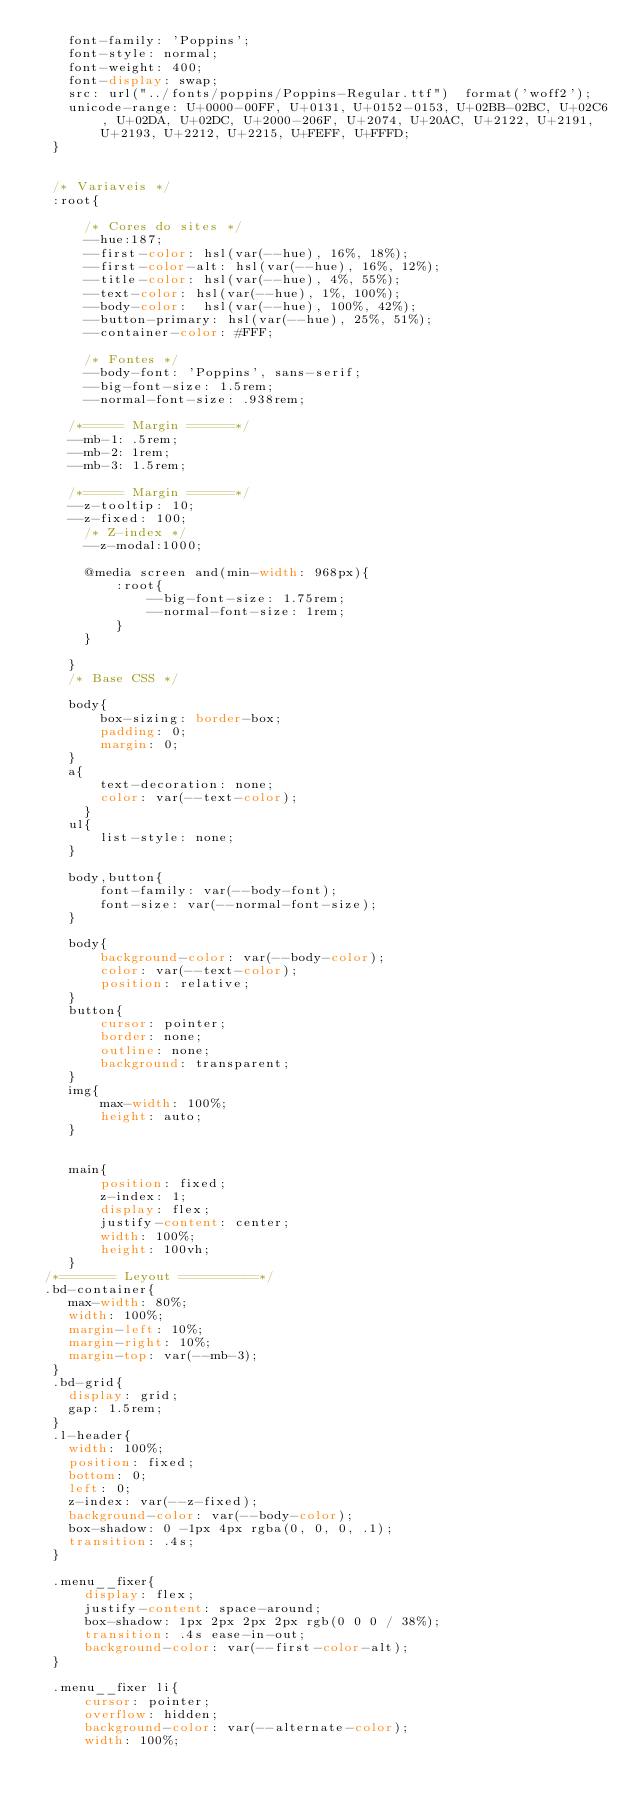<code> <loc_0><loc_0><loc_500><loc_500><_CSS_>    font-family: 'Poppins';
    font-style: normal;
    font-weight: 400;
    font-display: swap;
    src: url("../fonts/poppins/Poppins-Regular.ttf")  format('woff2');
    unicode-range: U+0000-00FF, U+0131, U+0152-0153, U+02BB-02BC, U+02C6, U+02DA, U+02DC, U+2000-206F, U+2074, U+20AC, U+2122, U+2191, U+2193, U+2212, U+2215, U+FEFF, U+FFFD;
  }
  

  /* Variaveis */
  :root{

      /* Cores do sites */
      --hue:187;
      --first-color: hsl(var(--hue), 16%, 18%);
      --first-color-alt: hsl(var(--hue), 16%, 12%);
      --title-color: hsl(var(--hue), 4%, 55%);
      --text-color: hsl(var(--hue), 1%, 100%);
      --body-color:  hsl(var(--hue), 100%, 42%);
      --button-primary: hsl(var(--hue), 25%, 51%);
      --container-color: #FFF;

      /* Fontes */
      --body-font: 'Poppins', sans-serif;
      --big-font-size: 1.5rem;
      --normal-font-size: .938rem;
    
    /*===== Margin ======*/
    --mb-1: .5rem;
    --mb-2: 1rem;
    --mb-3: 1.5rem;
  
    /*===== Margin ======*/
    --z-tooltip: 10;
    --z-fixed: 100;
      /* Z-index */
      --z-modal:1000;

      @media screen and(min-width: 968px){
          :root{
              --big-font-size: 1.75rem;
              --normal-font-size: 1rem;
          }
      }

    }
    /* Base CSS */ 
    
    body{
        box-sizing: border-box; 
        padding: 0;
        margin: 0;
    }
    a{
        text-decoration: none;
        color: var(--text-color);
      }
    ul{
        list-style: none;
    }

    body,button{
        font-family: var(--body-font);
        font-size: var(--normal-font-size);
    }

    body{
        background-color: var(--body-color);
        color: var(--text-color);
        position: relative;
    }
    button{
        cursor: pointer;
        border: none;
        outline: none;
        background: transparent;
    }
    img{
        max-width: 100%;
        height: auto;
    }


    main{
        position: fixed;
        z-index: 1;
        display: flex;
        justify-content: center;
        width: 100%;
        height: 100vh;
    }
 /*======= Leyout ==========*/
 .bd-container{
    max-width: 80%;
    width: 100%;
    margin-left: 10%;
    margin-right: 10%;
    margin-top: var(--mb-3);
  }
  .bd-grid{
    display: grid;
    gap: 1.5rem;
  }
  .l-header{
    width: 100%;
    position: fixed;
    bottom: 0;
    left: 0;
    z-index: var(--z-fixed);
    background-color: var(--body-color);
    box-shadow: 0 -1px 4px rgba(0, 0, 0, .1);
    transition: .4s;
  }

  .menu__fixer{
      display: flex;
      justify-content: space-around;
      box-shadow: 1px 2px 2px 2px rgb(0 0 0 / 38%);     
      transition: .4s ease-in-out;
      background-color: var(--first-color-alt);
  }

  .menu__fixer li{
      cursor: pointer;
      overflow: hidden;
      background-color: var(--alternate-color);
      width: 100%;</code> 